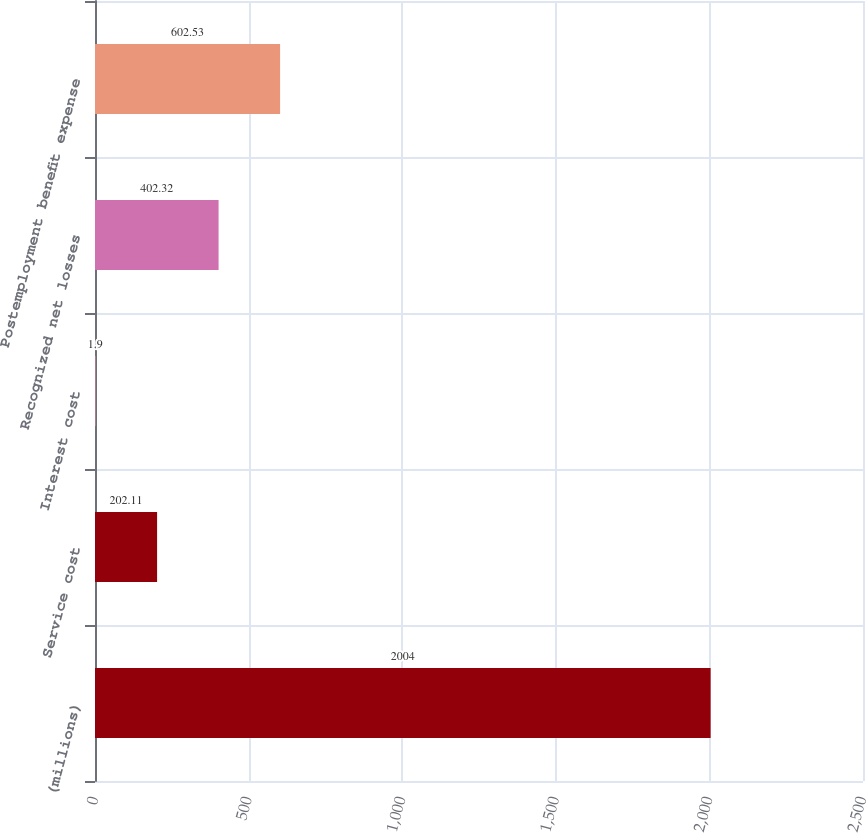Convert chart to OTSL. <chart><loc_0><loc_0><loc_500><loc_500><bar_chart><fcel>(millions)<fcel>Service cost<fcel>Interest cost<fcel>Recognized net losses<fcel>Postemployment benefit expense<nl><fcel>2004<fcel>202.11<fcel>1.9<fcel>402.32<fcel>602.53<nl></chart> 